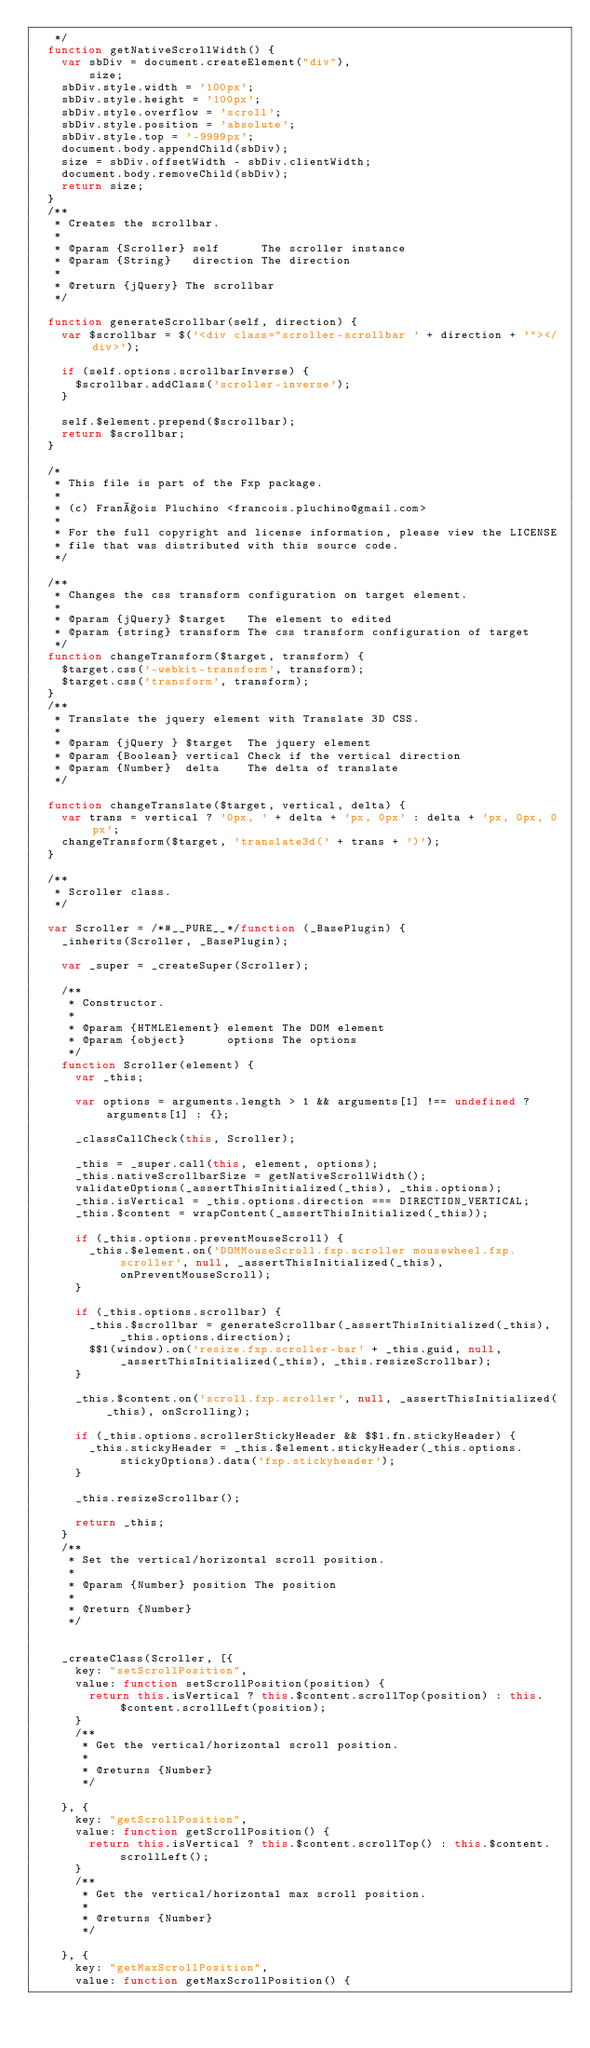<code> <loc_0><loc_0><loc_500><loc_500><_JavaScript_>   */
  function getNativeScrollWidth() {
    var sbDiv = document.createElement("div"),
        size;
    sbDiv.style.width = '100px';
    sbDiv.style.height = '100px';
    sbDiv.style.overflow = 'scroll';
    sbDiv.style.position = 'absolute';
    sbDiv.style.top = '-9999px';
    document.body.appendChild(sbDiv);
    size = sbDiv.offsetWidth - sbDiv.clientWidth;
    document.body.removeChild(sbDiv);
    return size;
  }
  /**
   * Creates the scrollbar.
   *
   * @param {Scroller} self      The scroller instance
   * @param {String}   direction The direction
   *
   * @return {jQuery} The scrollbar
   */

  function generateScrollbar(self, direction) {
    var $scrollbar = $('<div class="scroller-scrollbar ' + direction + '"></div>');

    if (self.options.scrollbarInverse) {
      $scrollbar.addClass('scroller-inverse');
    }

    self.$element.prepend($scrollbar);
    return $scrollbar;
  }

  /*
   * This file is part of the Fxp package.
   *
   * (c) François Pluchino <francois.pluchino@gmail.com>
   *
   * For the full copyright and license information, please view the LICENSE
   * file that was distributed with this source code.
   */

  /**
   * Changes the css transform configuration on target element.
   *
   * @param {jQuery} $target   The element to edited
   * @param {string} transform The css transform configuration of target
   */
  function changeTransform($target, transform) {
    $target.css('-webkit-transform', transform);
    $target.css('transform', transform);
  }
  /**
   * Translate the jquery element with Translate 3D CSS.
   *
   * @param {jQuery } $target  The jquery element
   * @param {Boolean} vertical Check if the vertical direction
   * @param {Number}  delta    The delta of translate
   */

  function changeTranslate($target, vertical, delta) {
    var trans = vertical ? '0px, ' + delta + 'px, 0px' : delta + 'px, 0px, 0px';
    changeTransform($target, 'translate3d(' + trans + ')');
  }

  /**
   * Scroller class.
   */

  var Scroller = /*#__PURE__*/function (_BasePlugin) {
    _inherits(Scroller, _BasePlugin);

    var _super = _createSuper(Scroller);

    /**
     * Constructor.
     *
     * @param {HTMLElement} element The DOM element
     * @param {object}      options The options
     */
    function Scroller(element) {
      var _this;

      var options = arguments.length > 1 && arguments[1] !== undefined ? arguments[1] : {};

      _classCallCheck(this, Scroller);

      _this = _super.call(this, element, options);
      _this.nativeScrollbarSize = getNativeScrollWidth();
      validateOptions(_assertThisInitialized(_this), _this.options);
      _this.isVertical = _this.options.direction === DIRECTION_VERTICAL;
      _this.$content = wrapContent(_assertThisInitialized(_this));

      if (_this.options.preventMouseScroll) {
        _this.$element.on('DOMMouseScroll.fxp.scroller mousewheel.fxp.scroller', null, _assertThisInitialized(_this), onPreventMouseScroll);
      }

      if (_this.options.scrollbar) {
        _this.$scrollbar = generateScrollbar(_assertThisInitialized(_this), _this.options.direction);
        $$1(window).on('resize.fxp.scroller-bar' + _this.guid, null, _assertThisInitialized(_this), _this.resizeScrollbar);
      }

      _this.$content.on('scroll.fxp.scroller', null, _assertThisInitialized(_this), onScrolling);

      if (_this.options.scrollerStickyHeader && $$1.fn.stickyHeader) {
        _this.stickyHeader = _this.$element.stickyHeader(_this.options.stickyOptions).data('fxp.stickyheader');
      }

      _this.resizeScrollbar();

      return _this;
    }
    /**
     * Set the vertical/horizontal scroll position.
     *
     * @param {Number} position The position
     *
     * @return {Number}
     */


    _createClass(Scroller, [{
      key: "setScrollPosition",
      value: function setScrollPosition(position) {
        return this.isVertical ? this.$content.scrollTop(position) : this.$content.scrollLeft(position);
      }
      /**
       * Get the vertical/horizontal scroll position.
       *
       * @returns {Number}
       */

    }, {
      key: "getScrollPosition",
      value: function getScrollPosition() {
        return this.isVertical ? this.$content.scrollTop() : this.$content.scrollLeft();
      }
      /**
       * Get the vertical/horizontal max scroll position.
       *
       * @returns {Number}
       */

    }, {
      key: "getMaxScrollPosition",
      value: function getMaxScrollPosition() {</code> 